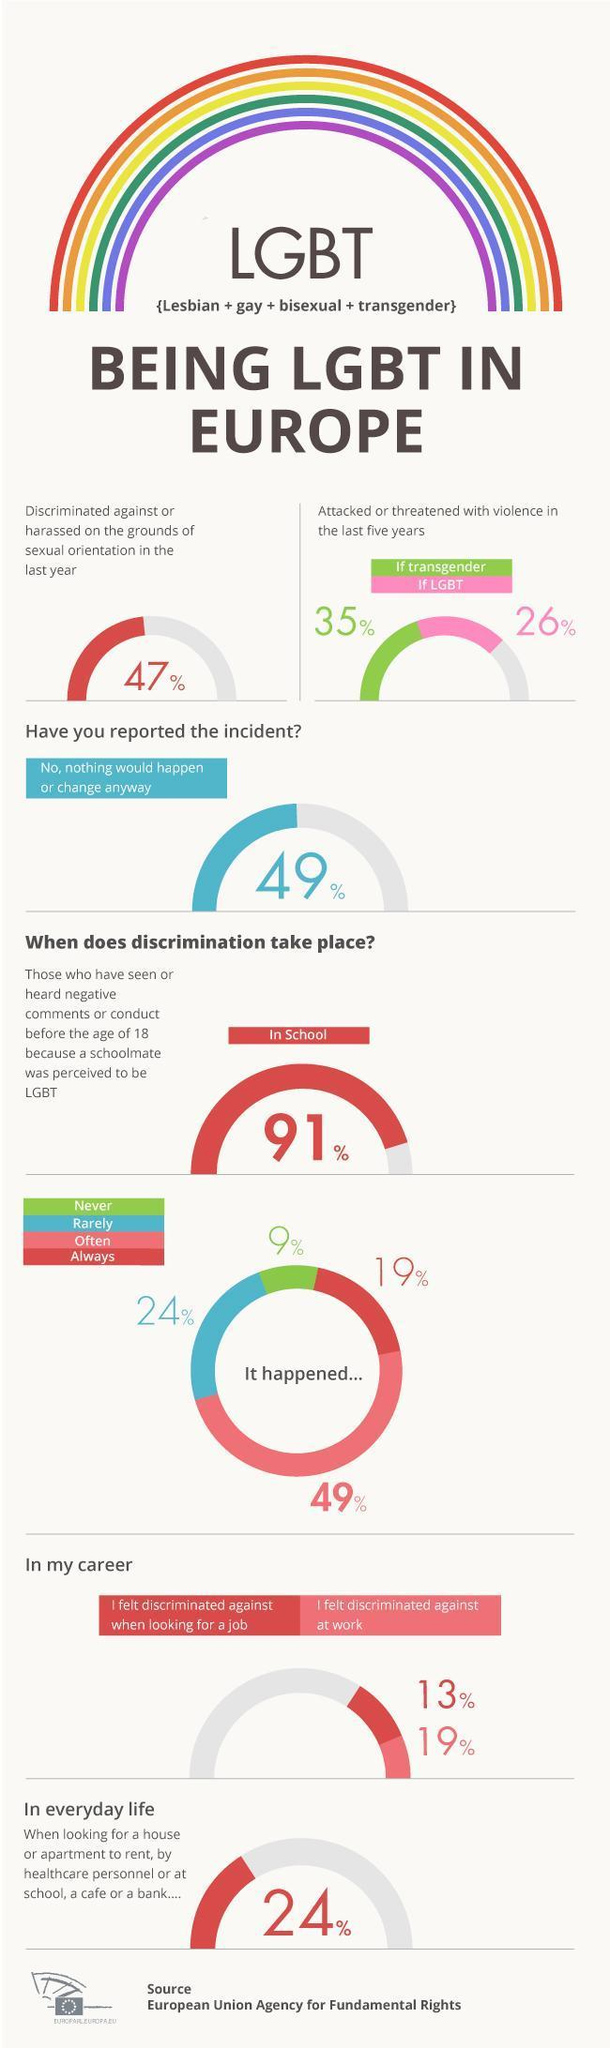What percentage of LGBT people in Europe were attacked or threatened with violence in the last five years?
Answer the question with a short phrase. 26% What percentage of LGBT people in Europe were discriminated on the basis of sexual orientation in the last year? 47% What percentage of transgender people in Europe were attacked or threatened with violence in the last five years? 35% What percentage of LGBT people in Europe felt discriminated against at work? 19% 